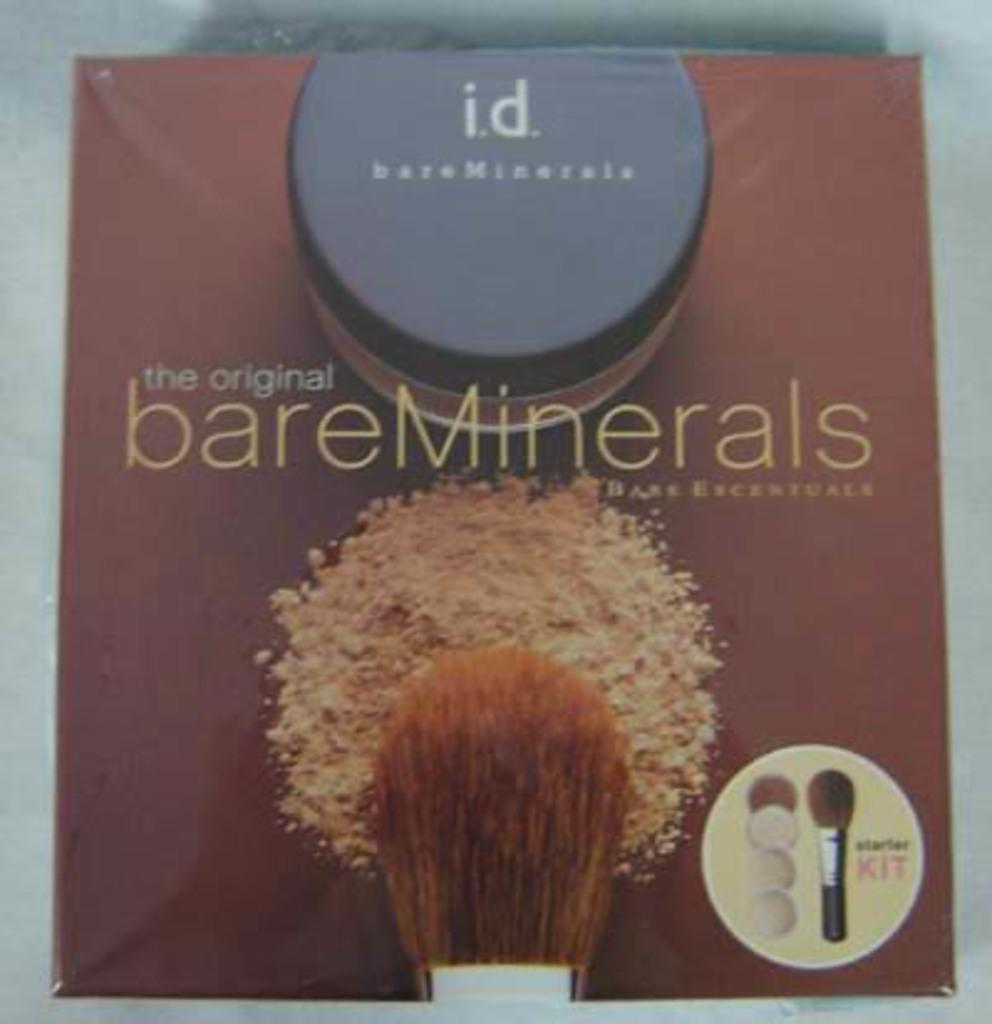<image>
Present a compact description of the photo's key features. Brush on top of a cover which says "The original bare Minerals". 